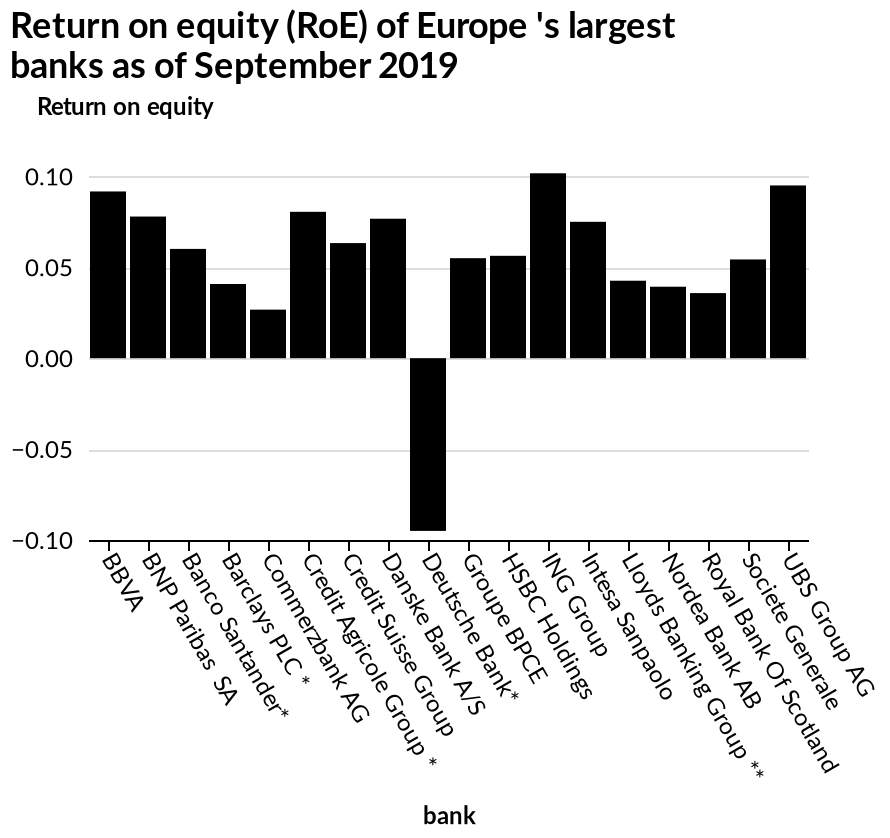<image>
please enumerates aspects of the construction of the chart Here a bar graph is labeled Return on equity (RoE) of Europe 's largest banks as of September 2019. The y-axis shows Return on equity while the x-axis shows bank. When was the data for the bar graph collected?  The data for the bar graph was collected as of September 2019. What is the RoE of the Deutsche Bank?  Negative Is a pie chart labeled Return on equity (RoE) of Europe's largest banks as of February 2020? No.Here a bar graph is labeled Return on equity (RoE) of Europe 's largest banks as of September 2019. The y-axis shows Return on equity while the x-axis shows bank. 